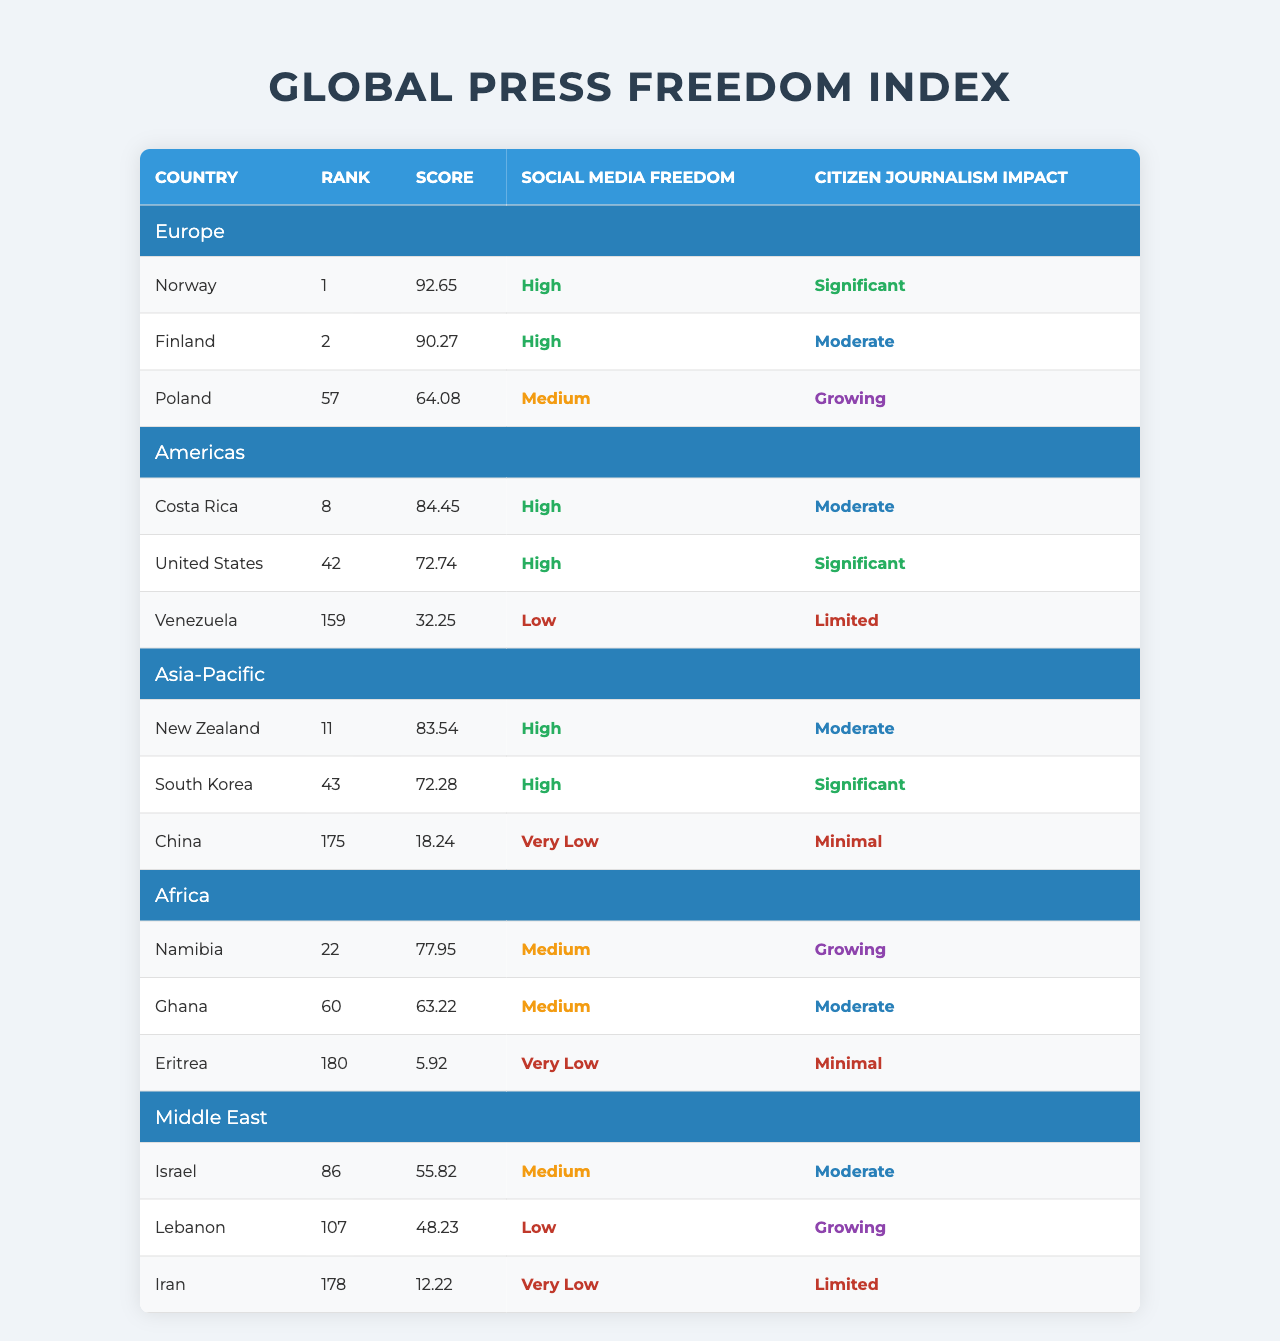What country has the highest score for press freedom in Europe? Norway has the highest score of 92.65, according to the table.
Answer: Norway Is the social media freedom in Venezuela high or low? The table shows that Venezuela has low social media freedom.
Answer: Low Which country in the Americas has a significant impact from citizen journalism? The United States has a significant impact from citizen journalism as indicated in the table.
Answer: United States How many countries in Asia-Pacific outrank China? New Zealand and South Korea both outrank China, meaning two countries have higher ranks than China's 175.
Answer: 2 What is the rank of Ghana according to the Global Press Freedom Index? Ghana's rank according to the table is 60.
Answer: 60 Do countries in Europe have better press freedom scores than those in the Middle East? Comparing the highest scores: Europe's Norway (92.65) is higher than the highest in the Middle East, which is Israel (55.82). Therefore, the answer is yes.
Answer: Yes What is the average score of the countries listed in the Africa region? The scores are 77.95 (Namibia), 63.22 (Ghana), and 5.92 (Eritrea). The average is (77.95 + 63.22 + 5.92) / 3 = 48.03.
Answer: 48.03 Which country has the lowest rank in the provided table? Eritrea has the lowest rank at 180, according to the table.
Answer: Eritrea What can you infer about the citizen journalism impact in countries with low social media freedom? Countries like Venezuela and China, which have low social media freedom, show limited to minimal citizen journalism impact, suggesting limitations for citizen journalists.
Answer: Limited impact If you were to list the countries in the Asia-Pacific region by score from highest to lowest, what would they be? The order is: New Zealand (83.54), South Korea (72.28), China (18.24).
Answer: New Zealand, South Korea, China 